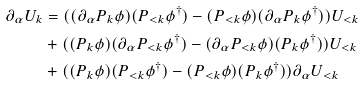Convert formula to latex. <formula><loc_0><loc_0><loc_500><loc_500>\partial _ { \alpha } U _ { k } & = ( ( \partial _ { \alpha } P _ { k } \phi ) ( P _ { < k } \phi ^ { \dagger } ) - ( P _ { < k } \phi ) ( \partial _ { \alpha } P _ { k } \phi ^ { \dagger } ) ) U _ { < k } \\ & + ( ( P _ { k } \phi ) ( \partial _ { \alpha } P _ { < k } \phi ^ { \dagger } ) - ( \partial _ { \alpha } P _ { < k } \phi ) ( P _ { k } \phi ^ { \dagger } ) ) U _ { < k } \\ & + ( ( P _ { k } \phi ) ( P _ { < k } \phi ^ { \dagger } ) - ( P _ { < k } \phi ) ( P _ { k } \phi ^ { \dagger } ) ) \partial _ { \alpha } U _ { < k }</formula> 